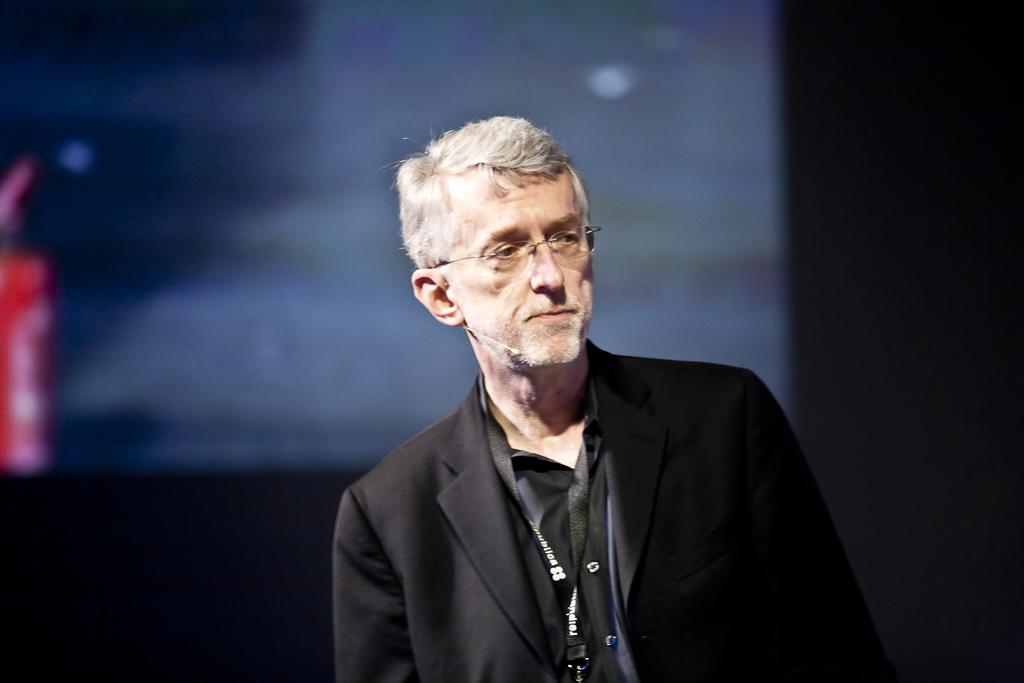What is present in the image? There is a person in the image. Can you describe the person's appearance? The person is wearing spectacles and clothes. How would you describe the background of the image? The background of the image is blurred. What type of fork is the person using to eat their lunch in the image? There is no fork or lunch present in the image; it only features a person with blurred background. 